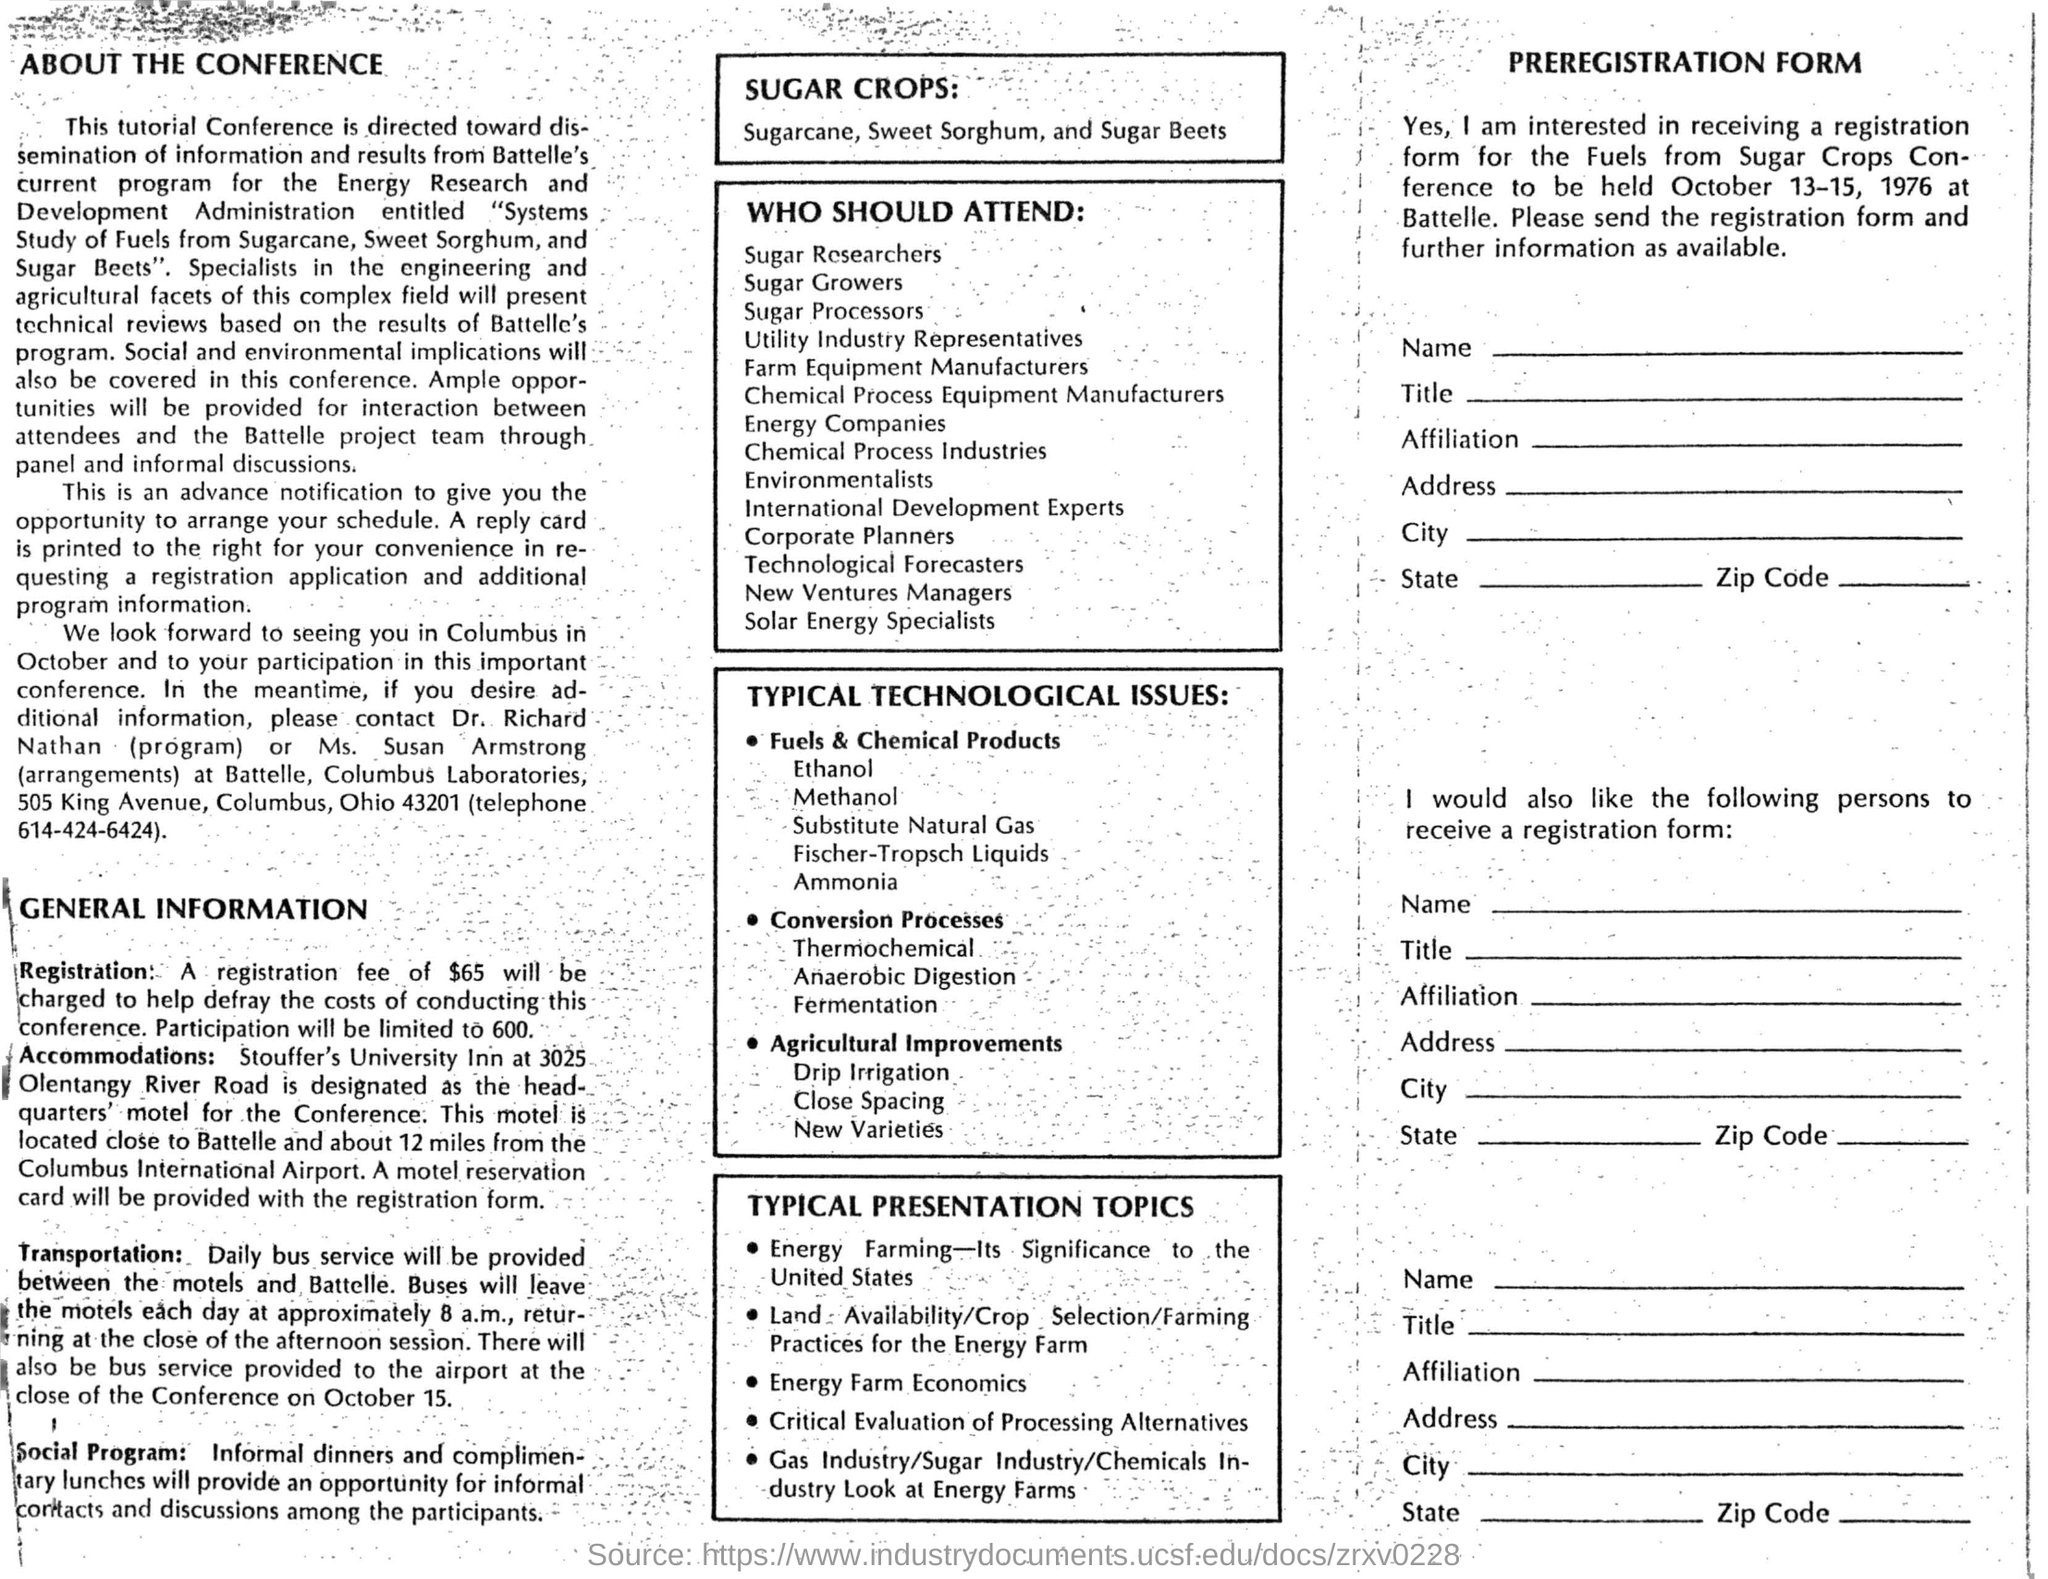Give some essential details in this illustration. The accommodations have been provided at Stouffer's University Inn. The conference is going to be held from October 13-15, 1976. The registration fee is $65. The conference document provided a list of sugar crops, including sugarcane, sweet sorghum, and sugar beets. The Stouffer's University Inn located at 3025 Olentangy River Road is designated as the headquarter's motel for the conference. 